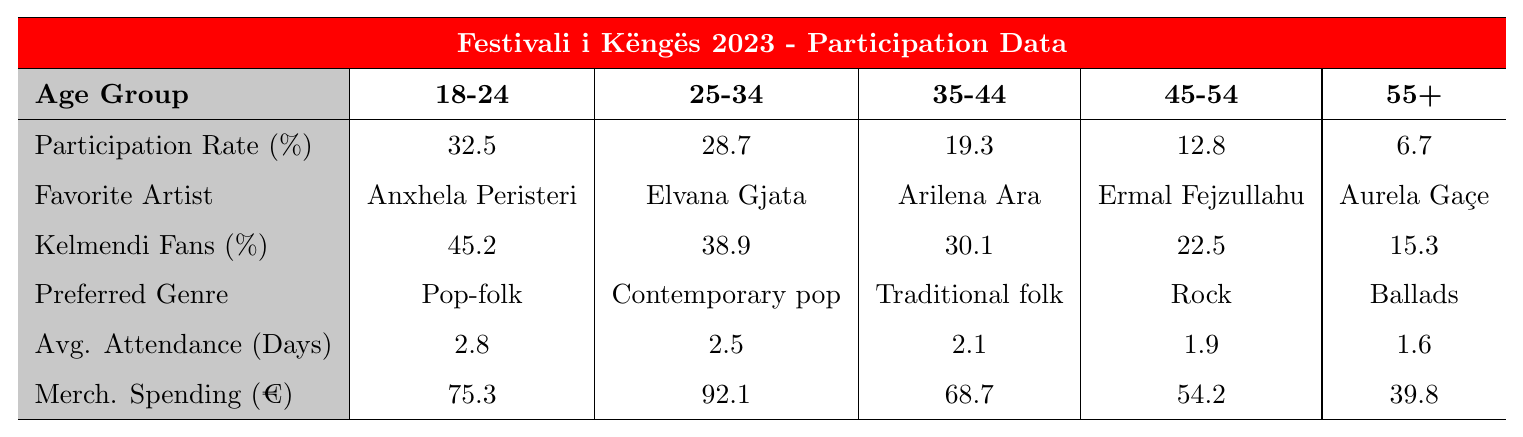What is the participation rate for the 18-24 age group? The table shows the participation rate for the 18-24 age group as 32.5%.
Answer: 32.5% Which age group has the highest participation rate? According to the table, the 18-24 age group has the highest participation rate at 32.5%.
Answer: 18-24 What is the favorite artist of the 35-44 age group? The table states that Arilena Ara is the favorite artist of the 35-44 age group.
Answer: Arilena Ara What percentage of fans in the 45-54 age group are Kelmendi fans? The table indicates that 22.5% of the 45-54 age group are Kelmendi fans.
Answer: 22.5% What is the average attendance in days for the 55+ age group? The table shows the average attendance for the 55+ age group is 1.6 days.
Answer: 1.6 Which age group spends the most on merchandise? The table indicates that the 25-34 age group spends the most on merchandise, with an expenditure of €92.1.
Answer: 25-34 What is the difference in participation rates between the 25-34 and 45-54 age groups? The participation rate for the 25-34 age group is 28.7%, and for the 45-54 age group, it is 12.8%. The difference is 28.7% - 12.8% = 15.9%.
Answer: 15.9% What is the average merchandise spending across all age groups? To calculate the average, sum the merchandise spending values (€75.3 + €92.1 + €68.7 + €54.2 + €39.8 = €330.1) and divide by 5, yielding an average of €66.02.
Answer: €66.02 Which age group has the lowest percentage of Kelmendi fans? The table shows that the 55+ age group has the lowest percentage of Kelmendi fans at 15.3%.
Answer: 55+ If we compare the preferred genres, which age group has 'Rock' as their favorite? According to the table, the 45-54 age group has 'Rock' as their preferred genre.
Answer: 45-54 Is the average attendance higher for the 25-34 age group compared to the 35-44 age group? Yes, the average attendance for the 25-34 age group is 2.5 days, which is higher than the 35-44 age group's average of 2.1 days.
Answer: Yes 